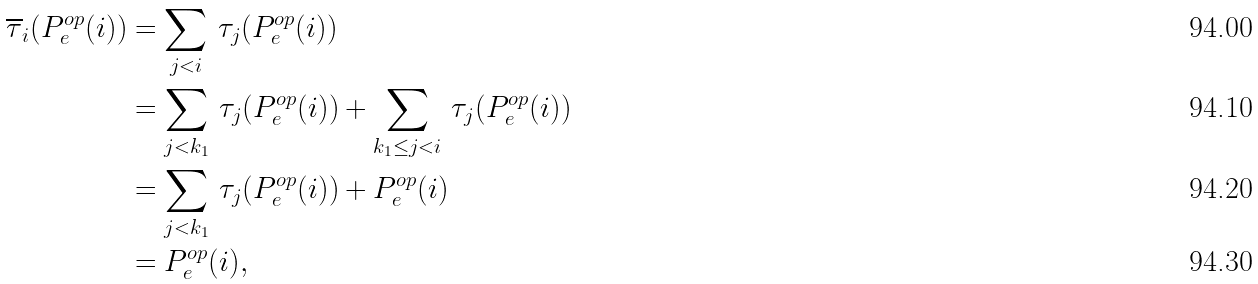<formula> <loc_0><loc_0><loc_500><loc_500>\overline { \tau } _ { i } ( P ^ { o p } _ { e } ( i ) ) & = \sum _ { j < i } \, \tau _ { j } ( P ^ { o p } _ { e } ( i ) ) \\ & = \sum _ { j < k _ { 1 } } \, \tau _ { j } ( P ^ { o p } _ { e } ( i ) ) + \sum _ { k _ { 1 } \leq j < i } \, \tau _ { j } ( P ^ { o p } _ { e } ( i ) ) \\ & = \sum _ { j < k _ { 1 } } \, \tau _ { j } ( P ^ { o p } _ { e } ( i ) ) + P ^ { o p } _ { e } ( i ) \\ & = P ^ { o p } _ { e } ( i ) ,</formula> 